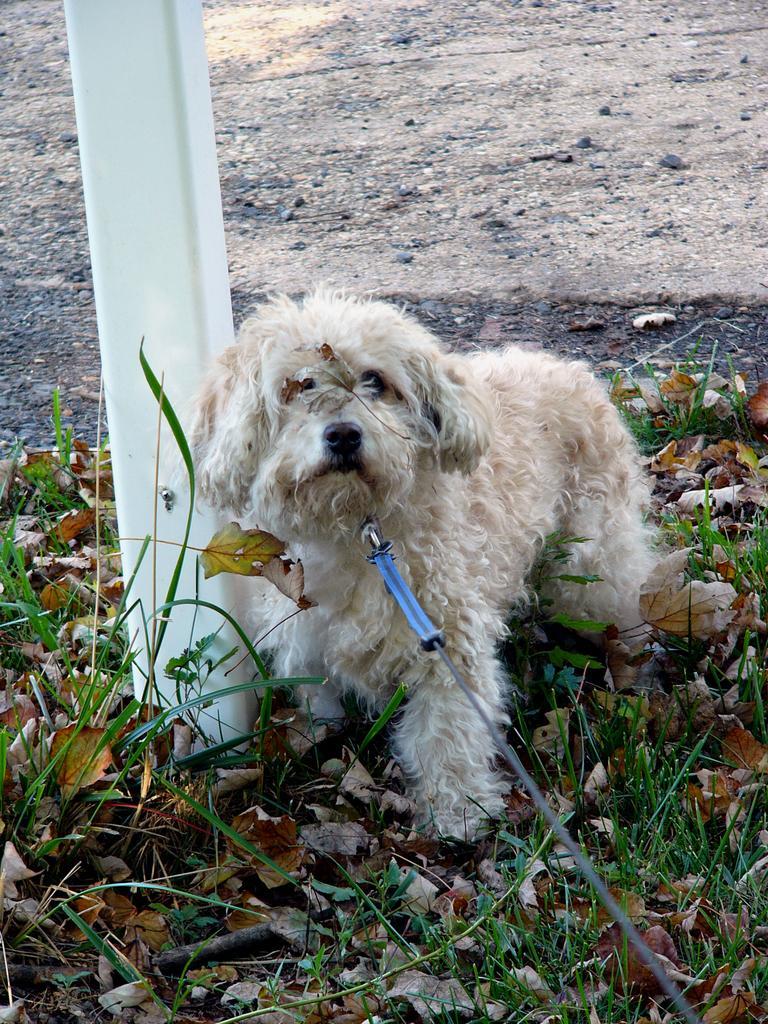In one or two sentences, can you explain what this image depicts? In the picture we can see a dog with a full of fur, which is cream in color on the path with some grass and beside the dog we can see a pole which is white in color and in the background we can see a muddy surface. 